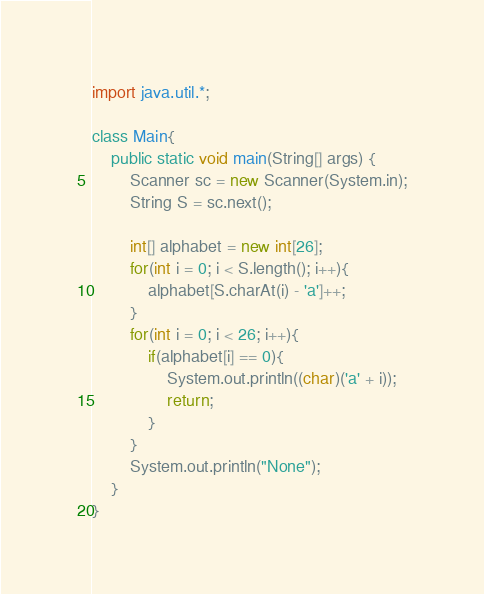<code> <loc_0><loc_0><loc_500><loc_500><_Java_>import java.util.*;

class Main{
    public static void main(String[] args) {
        Scanner sc = new Scanner(System.in);
        String S = sc.next();

        int[] alphabet = new int[26];
        for(int i = 0; i < S.length(); i++){
            alphabet[S.charAt(i) - 'a']++;
        }
        for(int i = 0; i < 26; i++){
            if(alphabet[i] == 0){
                System.out.println((char)('a' + i));
                return;
            }
        }
        System.out.println("None");
    }
}
</code> 